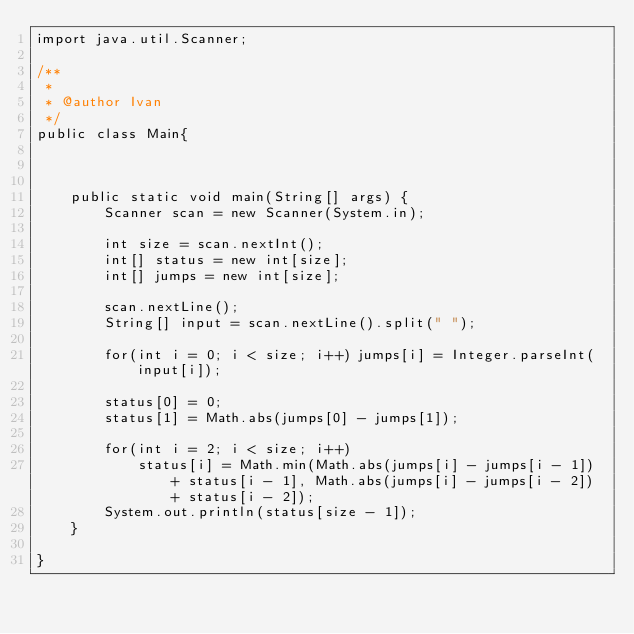<code> <loc_0><loc_0><loc_500><loc_500><_Java_>import java.util.Scanner;

/**
 *
 * @author Ivan
 */
public class Main{
    
   
    
    public static void main(String[] args) {
        Scanner scan = new Scanner(System.in);
        
        int size = scan.nextInt();
        int[] status = new int[size];
        int[] jumps = new int[size];
        
        scan.nextLine();
        String[] input = scan.nextLine().split(" ");
        
        for(int i = 0; i < size; i++) jumps[i] = Integer.parseInt(input[i]);
        
        status[0] = 0;
        status[1] = Math.abs(jumps[0] - jumps[1]);
        
        for(int i = 2; i < size; i++)
            status[i] = Math.min(Math.abs(jumps[i] - jumps[i - 1]) + status[i - 1], Math.abs(jumps[i] - jumps[i - 2]) + status[i - 2]);
        System.out.println(status[size - 1]);
    }
    
}</code> 